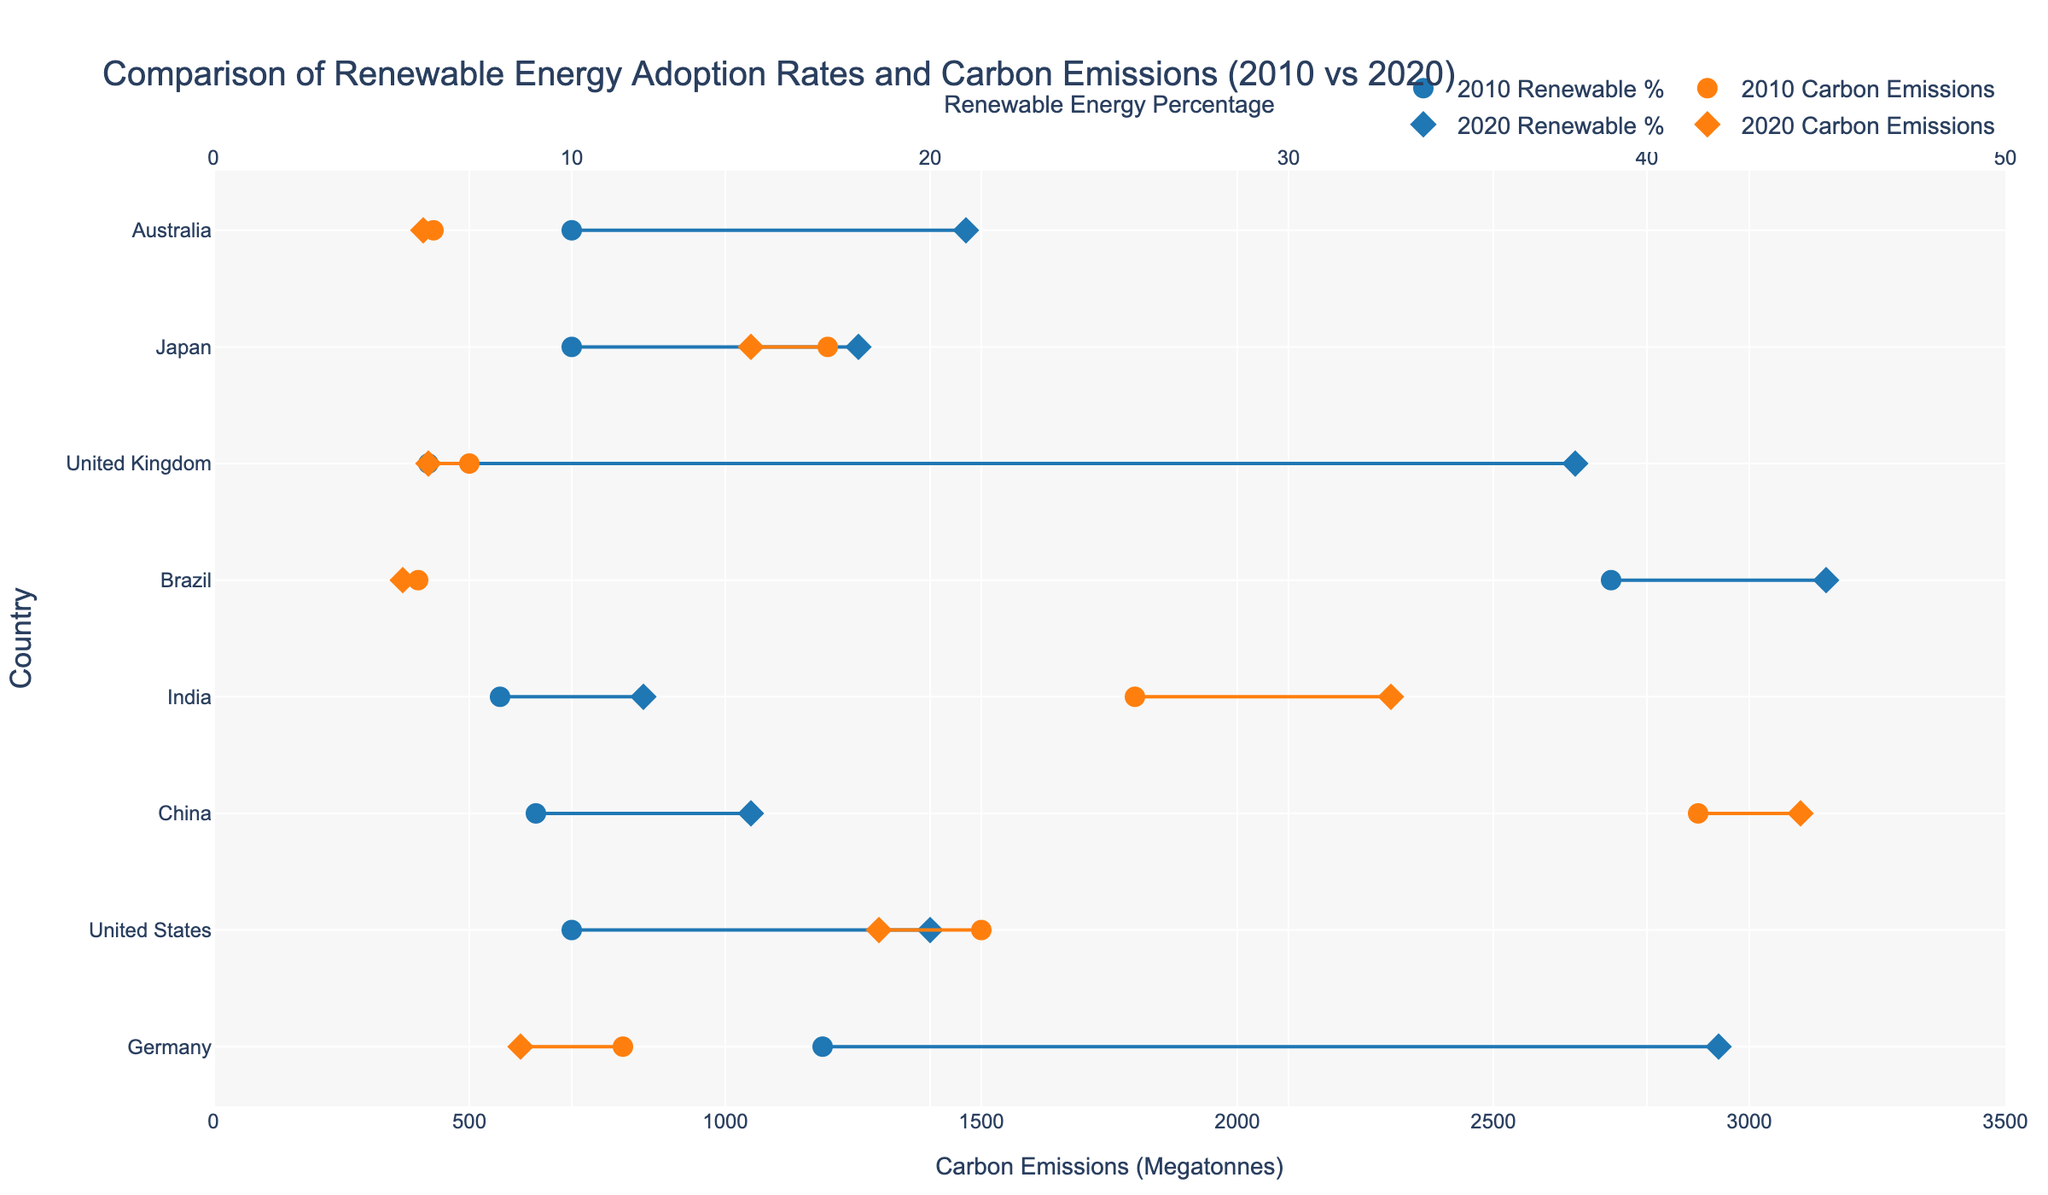Which country had the highest percentage increase in renewable energy from 2010 to 2020? To determine the country with the highest percentage increase in renewable energy, examine the 2010 and 2020 markers for each country and calculate the difference between the two years. The country with the largest increase will have the highest value.
Answer: United Kingdom Which country reduced its carbon emissions the most from 2010 to 2020? To find the country with the most significant reduction, compare the carbon emissions markers for 2010 and 2020 for each country and calculate the absolute difference. The country with the largest decrease will have the most significant reduction.
Answer: United States Between 2010 and 2020, which country had the smallest change in its renewable energy percentage? Check the markers for renewable energy percentage in 2010 and 2020 for each country and identify the country with the smallest difference between the two years.
Answer: Brazil Which country had the highest carbon emissions in 2020? Look at the markers for carbon emissions in 2020 and identify the country with the highest value.
Answer: China How many countries had an increase in renewable energy percentage from 2010 to 2020? Compare the renewable energy percentages of 2010 and 2020 for each country and count the number of countries where the 2020 percentage is higher than that of 2010.
Answer: 7 For which country did the renewable energy percentage almost triple between 2010 and 2020? To identify the country, calculate the ratio of the 2020 renewable energy percentage to the 2010 percentage and find the country where this ratio is closest to 3.
Answer: United Kingdom Which countries recorded an increase in both renewable energy percentage and carbon emissions from 2010 to 2020? Compare both the renewable energy percentage and carbon emissions for 2010 and 2020, and identify countries where both values increased.
Answer: China, India What is the average renewable energy percentage in 2020 across all listed countries? Sum the renewable energy percentages for all countries in 2020 and divide by the number of countries to find the average. (42+20+15+12+45+38+18+21)/8 = 26.375
Answer: 26.375 Which country had the highest combined value of renewable energy percentage in 2020 and carbon emissions in 2020? Add the renewable energy percentage and carbon emissions values for each country in 2020, and find the highest total.
Answer: China How much did carbon emissions change on average across all countries from 2010 to 2020? Calculate the change in carbon emissions for each country and then find the average of these changes. (200 + (-200) + 200 + 500 + (-30) + (-80) + (-150) + (-20))/8 = 52.5
Answer: 52.5 